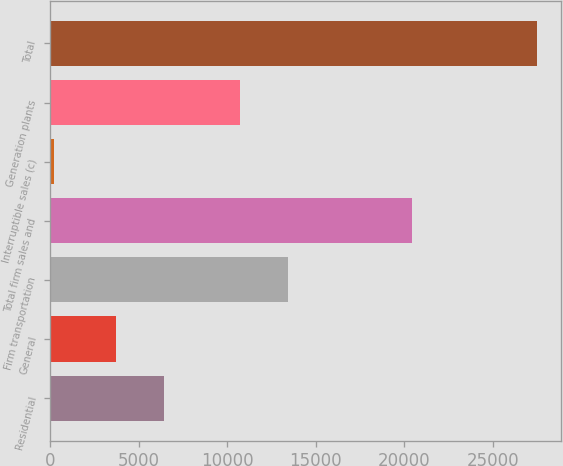<chart> <loc_0><loc_0><loc_500><loc_500><bar_chart><fcel>Residential<fcel>General<fcel>Firm transportation<fcel>Total firm sales and<fcel>Interruptible sales (c)<fcel>Generation plants<fcel>Total<nl><fcel>6458<fcel>3729<fcel>13453<fcel>20419<fcel>202<fcel>10724<fcel>27492<nl></chart> 